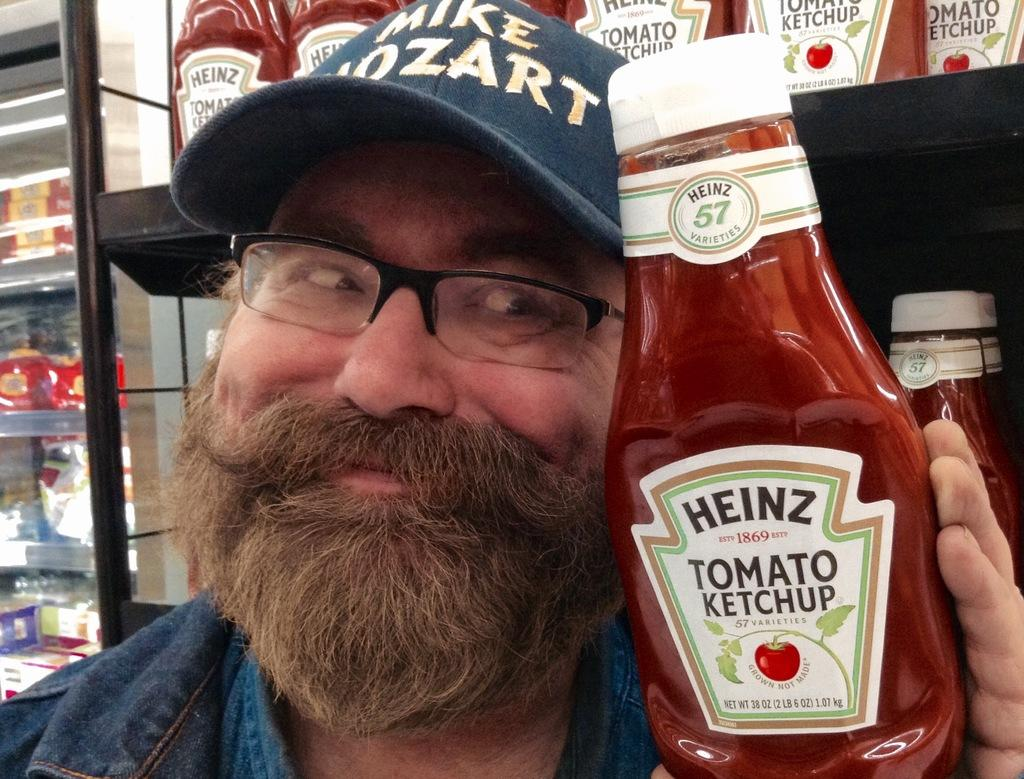What is the person holding in the image? The person is holding a bottle. What type of headwear is the person wearing? The person is wearing a cap. What type of eyewear is the person wearing? The person is wearing a spectacle. What is the facial expression of the person in the image? The person is smiling. What can be seen in the background of the image? There is a shop and a pole in the background of the image. What type of government is depicted in the image? There is no depiction of a government in the image; it features a person holding a bottle, wearing a cap and spectacle, and smiling, with a shop and pole in the background. 